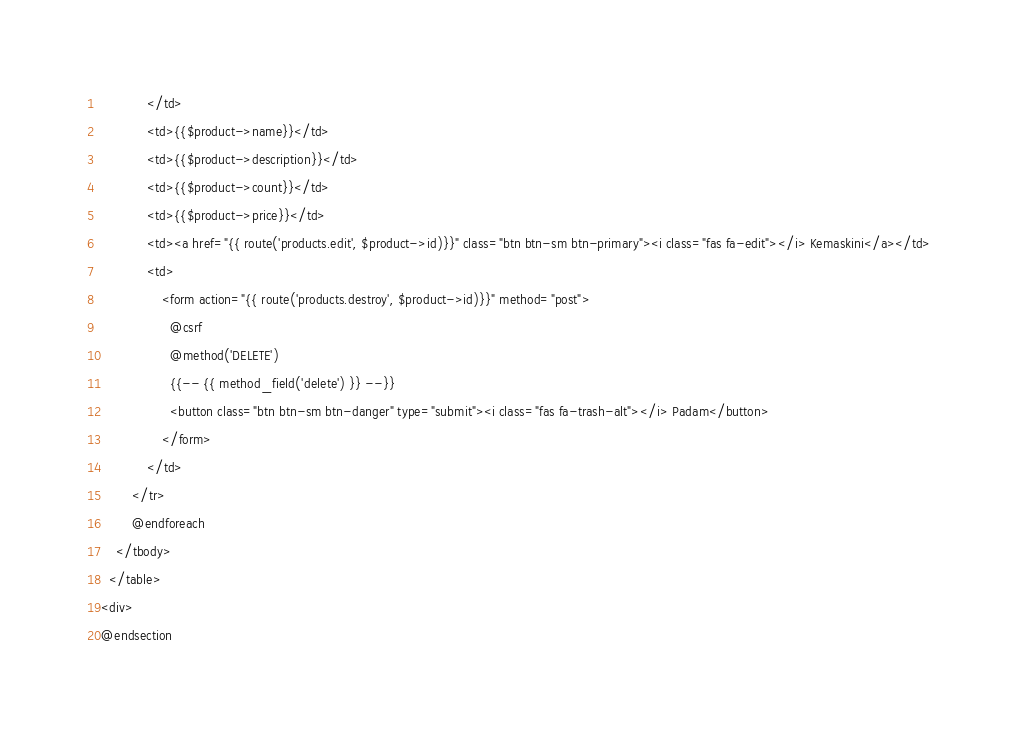Convert code to text. <code><loc_0><loc_0><loc_500><loc_500><_PHP_>            </td>
            <td>{{$product->name}}</td>
            <td>{{$product->description}}</td>
            <td>{{$product->count}}</td>
            <td>{{$product->price}}</td>
            <td><a href="{{ route('products.edit', $product->id)}}" class="btn btn-sm btn-primary"><i class="fas fa-edit"></i> Kemaskini</a></td>
            <td>
                <form action="{{ route('products.destroy', $product->id)}}" method="post">
                  @csrf
                  @method('DELETE')
                  {{-- {{ method_field('delete') }} --}}
                  <button class="btn btn-sm btn-danger" type="submit"><i class="fas fa-trash-alt"></i> Padam</button>
                </form>
            </td>
        </tr>
        @endforeach
    </tbody>
  </table>
<div>
@endsection</code> 